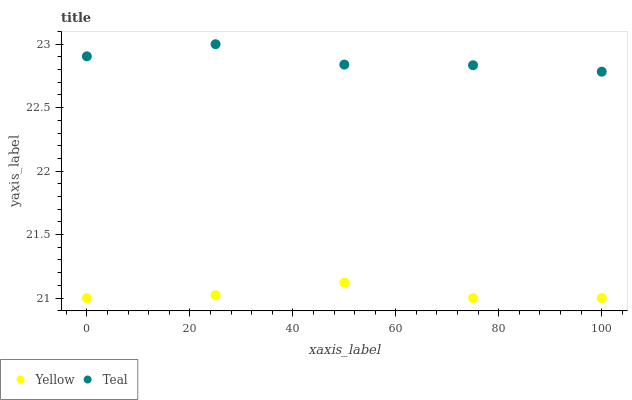Does Yellow have the minimum area under the curve?
Answer yes or no. Yes. Does Teal have the maximum area under the curve?
Answer yes or no. Yes. Does Yellow have the maximum area under the curve?
Answer yes or no. No. Is Yellow the smoothest?
Answer yes or no. Yes. Is Teal the roughest?
Answer yes or no. Yes. Is Yellow the roughest?
Answer yes or no. No. Does Yellow have the lowest value?
Answer yes or no. Yes. Does Teal have the highest value?
Answer yes or no. Yes. Does Yellow have the highest value?
Answer yes or no. No. Is Yellow less than Teal?
Answer yes or no. Yes. Is Teal greater than Yellow?
Answer yes or no. Yes. Does Yellow intersect Teal?
Answer yes or no. No. 